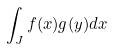Convert formula to latex. <formula><loc_0><loc_0><loc_500><loc_500>\int _ { J } f ( x ) g ( y ) d x</formula> 